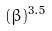<formula> <loc_0><loc_0><loc_500><loc_500>( \beta ) ^ { 3 . 5 }</formula> 